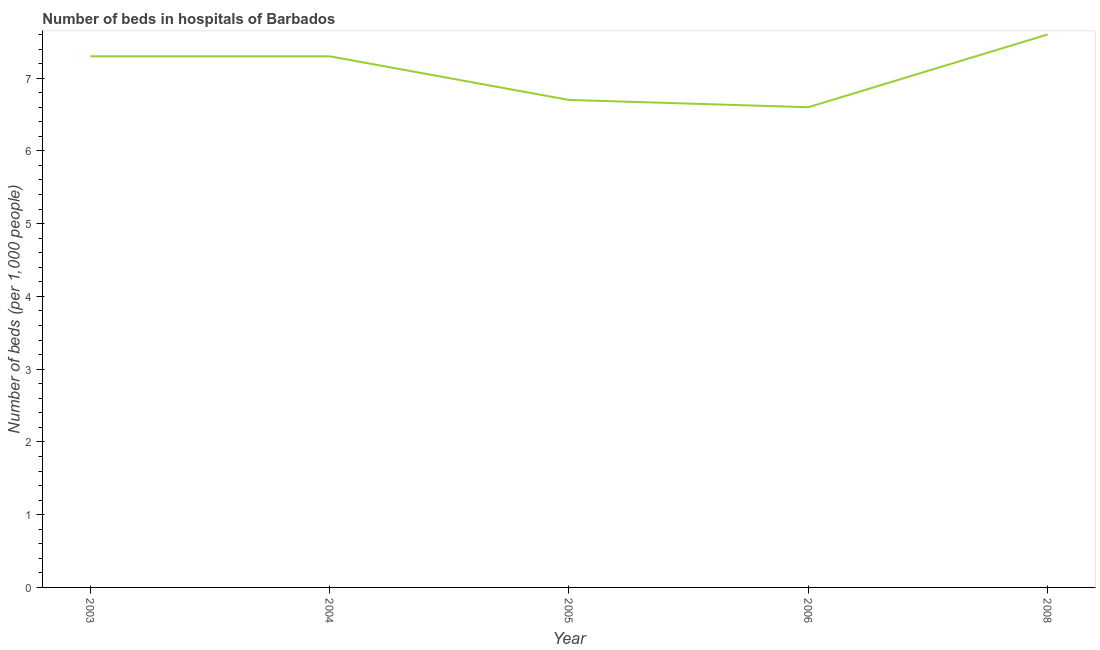In which year was the number of hospital beds maximum?
Keep it short and to the point. 2008. In which year was the number of hospital beds minimum?
Ensure brevity in your answer.  2006. What is the sum of the number of hospital beds?
Offer a terse response. 35.5. What is the difference between the number of hospital beds in 2003 and 2008?
Your answer should be compact. -0.3. What is the median number of hospital beds?
Provide a short and direct response. 7.3. In how many years, is the number of hospital beds greater than 5 %?
Your answer should be very brief. 5. What is the ratio of the number of hospital beds in 2004 to that in 2006?
Offer a terse response. 1.11. Is the number of hospital beds in 2003 less than that in 2004?
Offer a very short reply. No. Is the difference between the number of hospital beds in 2003 and 2008 greater than the difference between any two years?
Provide a succinct answer. No. What is the difference between the highest and the second highest number of hospital beds?
Your answer should be compact. 0.3. What is the difference between the highest and the lowest number of hospital beds?
Keep it short and to the point. 1. In how many years, is the number of hospital beds greater than the average number of hospital beds taken over all years?
Your answer should be compact. 3. Does the number of hospital beds monotonically increase over the years?
Keep it short and to the point. No. How many lines are there?
Provide a short and direct response. 1. How many years are there in the graph?
Provide a short and direct response. 5. What is the difference between two consecutive major ticks on the Y-axis?
Provide a short and direct response. 1. Does the graph contain grids?
Your answer should be compact. No. What is the title of the graph?
Ensure brevity in your answer.  Number of beds in hospitals of Barbados. What is the label or title of the Y-axis?
Your answer should be compact. Number of beds (per 1,0 people). What is the Number of beds (per 1,000 people) in 2006?
Give a very brief answer. 6.6. What is the Number of beds (per 1,000 people) of 2008?
Offer a terse response. 7.6. What is the difference between the Number of beds (per 1,000 people) in 2003 and 2006?
Your response must be concise. 0.7. What is the difference between the Number of beds (per 1,000 people) in 2003 and 2008?
Offer a terse response. -0.3. What is the difference between the Number of beds (per 1,000 people) in 2004 and 2005?
Your response must be concise. 0.6. What is the difference between the Number of beds (per 1,000 people) in 2004 and 2006?
Your answer should be very brief. 0.7. What is the difference between the Number of beds (per 1,000 people) in 2004 and 2008?
Your response must be concise. -0.3. What is the difference between the Number of beds (per 1,000 people) in 2005 and 2008?
Make the answer very short. -0.9. What is the difference between the Number of beds (per 1,000 people) in 2006 and 2008?
Your response must be concise. -1. What is the ratio of the Number of beds (per 1,000 people) in 2003 to that in 2004?
Give a very brief answer. 1. What is the ratio of the Number of beds (per 1,000 people) in 2003 to that in 2005?
Provide a short and direct response. 1.09. What is the ratio of the Number of beds (per 1,000 people) in 2003 to that in 2006?
Make the answer very short. 1.11. What is the ratio of the Number of beds (per 1,000 people) in 2004 to that in 2005?
Keep it short and to the point. 1.09. What is the ratio of the Number of beds (per 1,000 people) in 2004 to that in 2006?
Your response must be concise. 1.11. What is the ratio of the Number of beds (per 1,000 people) in 2004 to that in 2008?
Your answer should be very brief. 0.96. What is the ratio of the Number of beds (per 1,000 people) in 2005 to that in 2006?
Offer a very short reply. 1.01. What is the ratio of the Number of beds (per 1,000 people) in 2005 to that in 2008?
Your answer should be very brief. 0.88. What is the ratio of the Number of beds (per 1,000 people) in 2006 to that in 2008?
Ensure brevity in your answer.  0.87. 